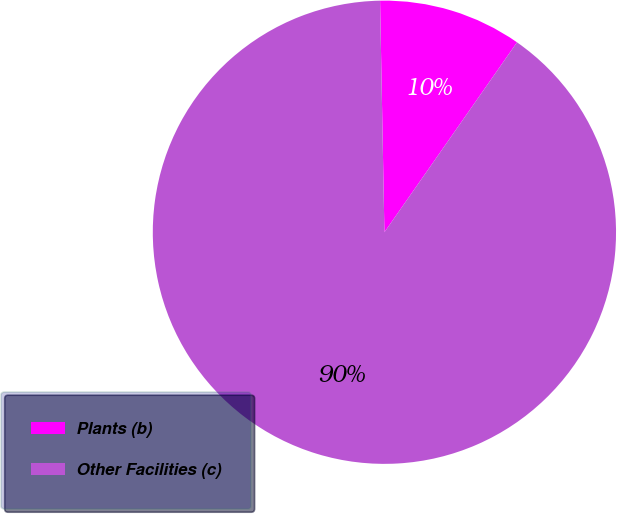Convert chart to OTSL. <chart><loc_0><loc_0><loc_500><loc_500><pie_chart><fcel>Plants (b)<fcel>Other Facilities (c)<nl><fcel>10.0%<fcel>90.0%<nl></chart> 